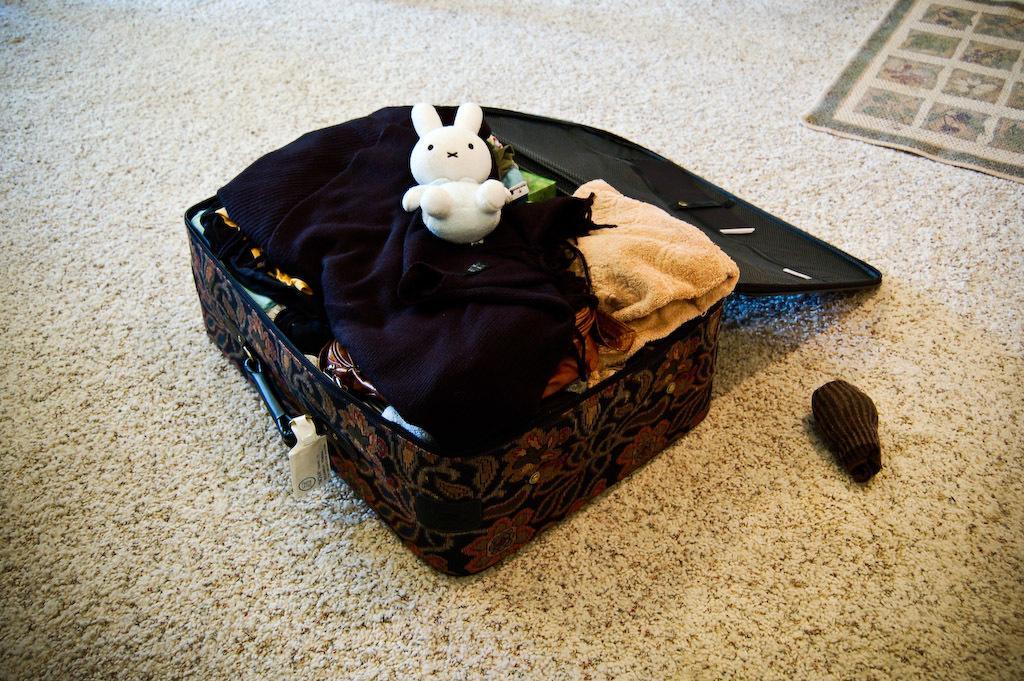Could you give a brief overview of what you see in this image? In this image I can see the suitcase and few clothes and the white color toy in the suitcase. I can see the floor mat, brown color cloth and the suitcase is on the white color surface. 